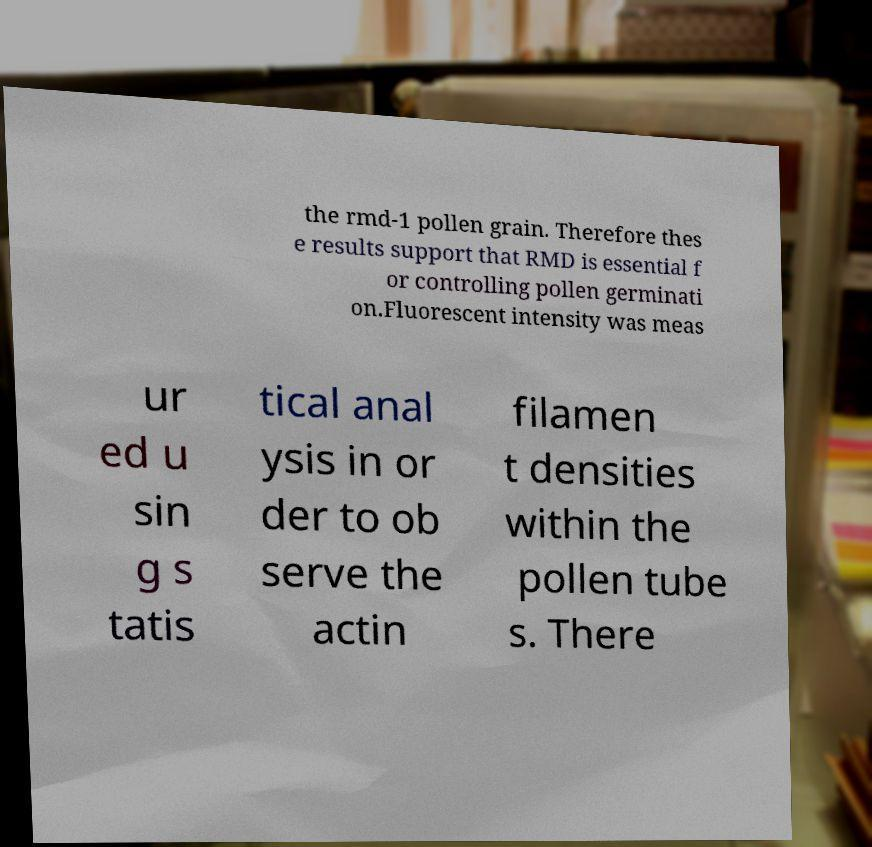What messages or text are displayed in this image? I need them in a readable, typed format. the rmd-1 pollen grain. Therefore thes e results support that RMD is essential f or controlling pollen germinati on.Fluorescent intensity was meas ur ed u sin g s tatis tical anal ysis in or der to ob serve the actin filamen t densities within the pollen tube s. There 